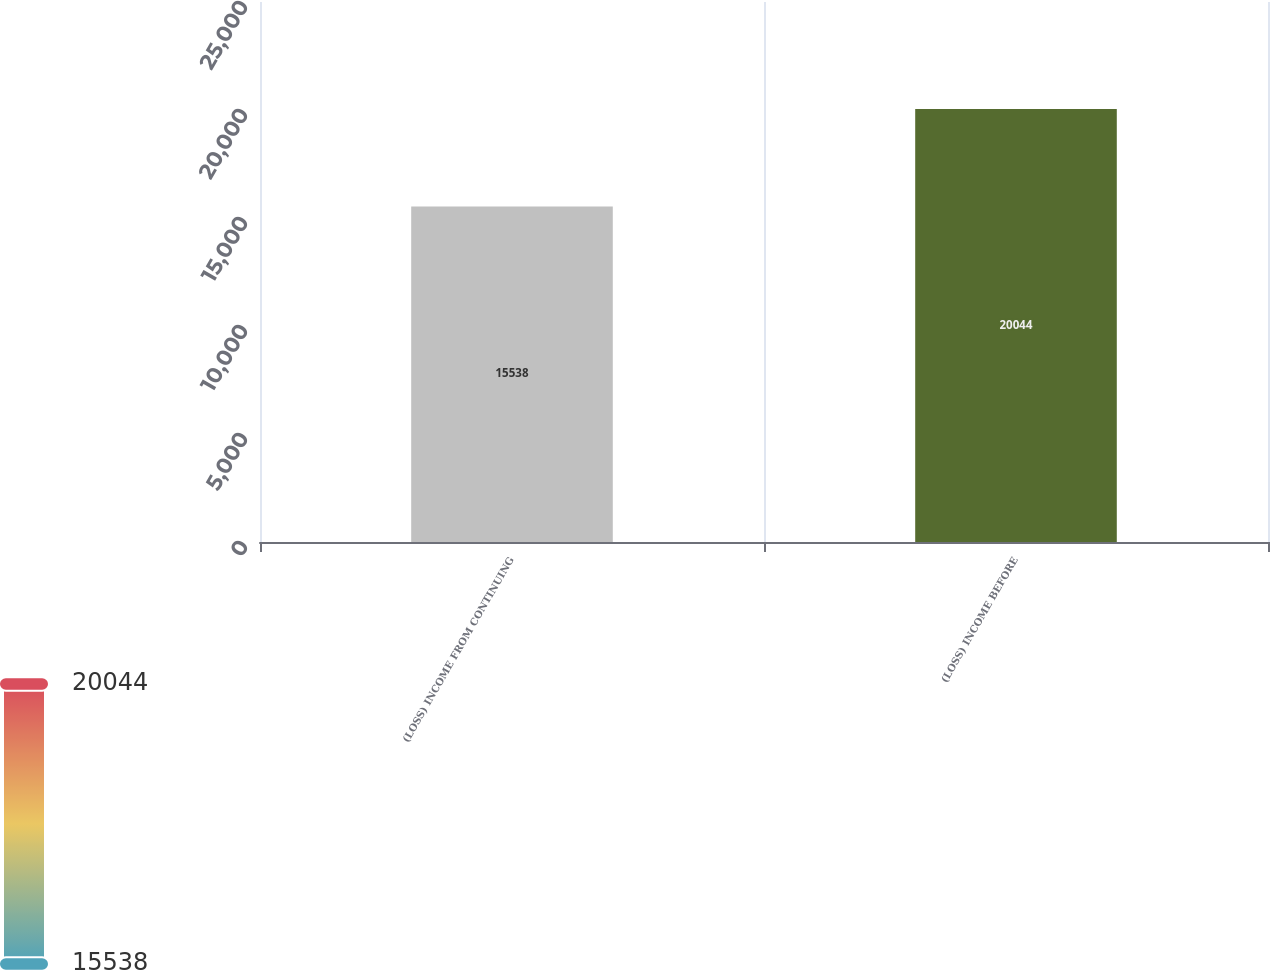<chart> <loc_0><loc_0><loc_500><loc_500><bar_chart><fcel>(LOSS) INCOME FROM CONTINUING<fcel>(LOSS) INCOME BEFORE<nl><fcel>15538<fcel>20044<nl></chart> 